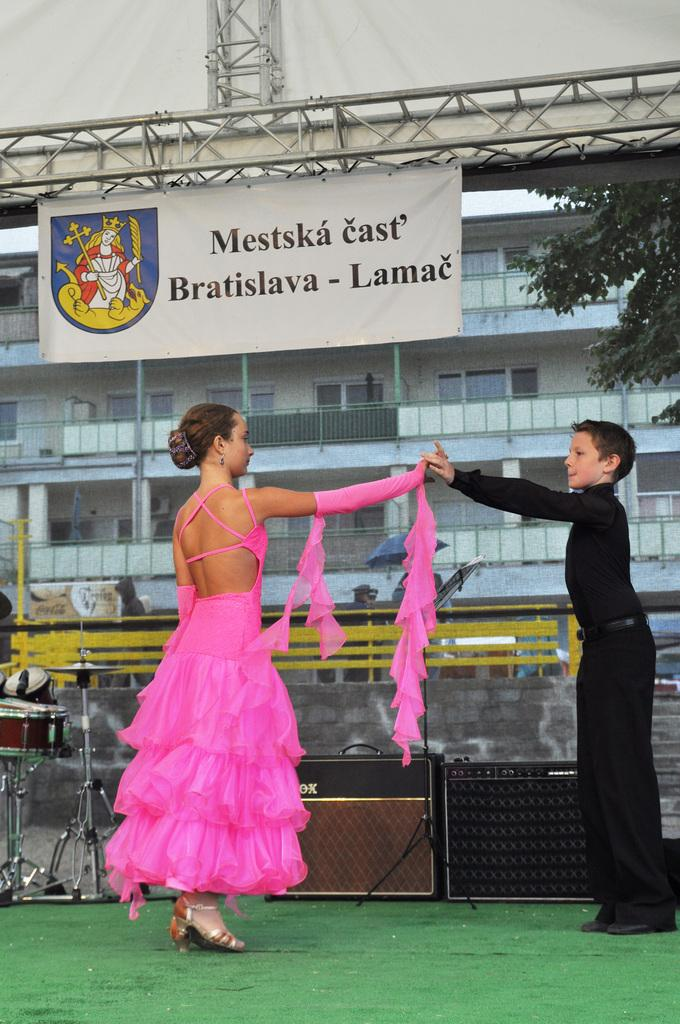Who can be seen in the foreground of the picture? There is a girl and a boy in the foreground of the picture. What are they doing in the picture? They are dancing on a stage. What can be seen in the background of the picture? There is a banner, a tent, a railing, a building, and trees in the background of the picture. What color are the eyes of the ice sculpture in the picture? There is no ice sculpture present in the picture, so it is not possible to determine the color of its eyes. 